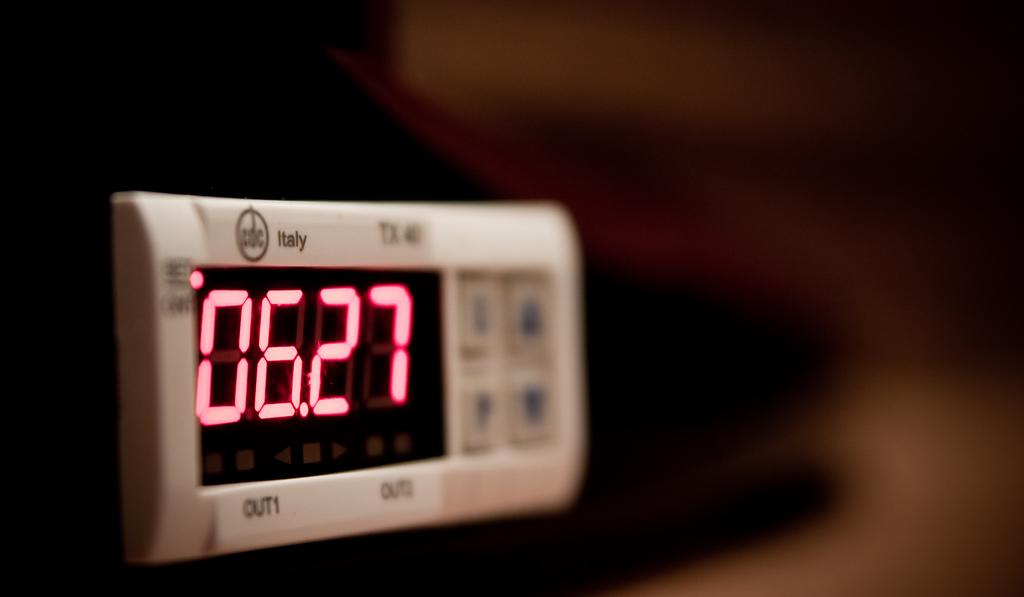What time is shown on this clock?
Your response must be concise. 06:27. What country is written on the clock?
Provide a succinct answer. Italy. 